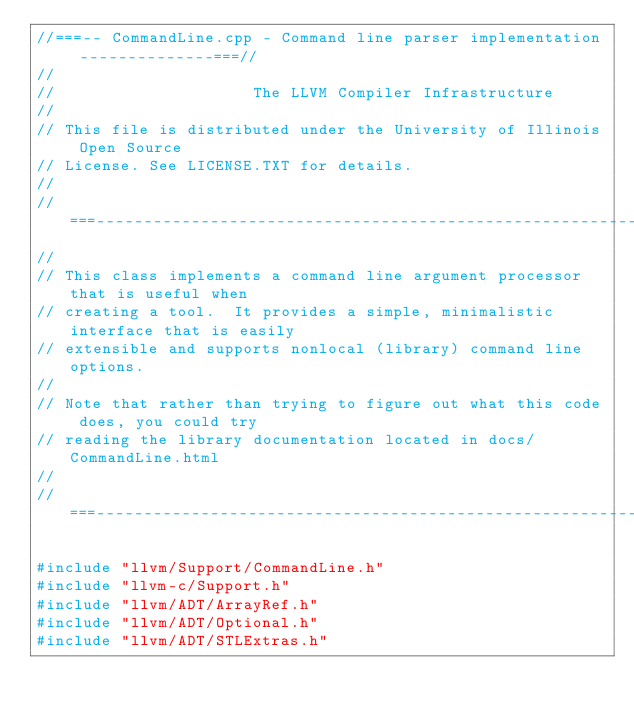<code> <loc_0><loc_0><loc_500><loc_500><_C++_>//===-- CommandLine.cpp - Command line parser implementation --------------===//
//
//                     The LLVM Compiler Infrastructure
//
// This file is distributed under the University of Illinois Open Source
// License. See LICENSE.TXT for details.
//
//===----------------------------------------------------------------------===//
//
// This class implements a command line argument processor that is useful when
// creating a tool.  It provides a simple, minimalistic interface that is easily
// extensible and supports nonlocal (library) command line options.
//
// Note that rather than trying to figure out what this code does, you could try
// reading the library documentation located in docs/CommandLine.html
//
//===----------------------------------------------------------------------===//

#include "llvm/Support/CommandLine.h"
#include "llvm-c/Support.h"
#include "llvm/ADT/ArrayRef.h"
#include "llvm/ADT/Optional.h"
#include "llvm/ADT/STLExtras.h"</code> 